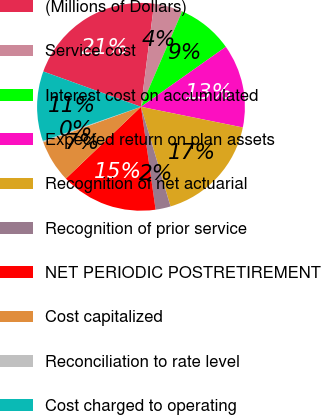Convert chart. <chart><loc_0><loc_0><loc_500><loc_500><pie_chart><fcel>(Millions of Dollars)<fcel>Service cost<fcel>Interest cost on accumulated<fcel>Expected return on plan assets<fcel>Recognition of net actuarial<fcel>Recognition of prior service<fcel>NET PERIODIC POSTRETIREMENT<fcel>Cost capitalized<fcel>Reconciliation to rate level<fcel>Cost charged to operating<nl><fcel>21.49%<fcel>4.47%<fcel>8.72%<fcel>12.98%<fcel>17.23%<fcel>2.34%<fcel>15.11%<fcel>6.6%<fcel>0.21%<fcel>10.85%<nl></chart> 